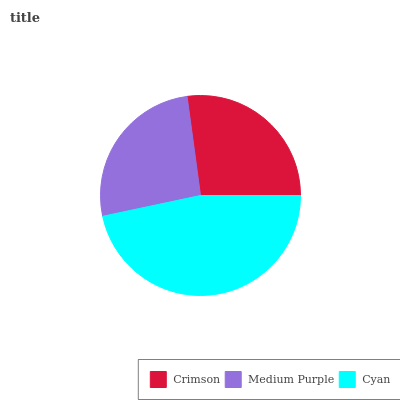Is Medium Purple the minimum?
Answer yes or no. Yes. Is Cyan the maximum?
Answer yes or no. Yes. Is Cyan the minimum?
Answer yes or no. No. Is Medium Purple the maximum?
Answer yes or no. No. Is Cyan greater than Medium Purple?
Answer yes or no. Yes. Is Medium Purple less than Cyan?
Answer yes or no. Yes. Is Medium Purple greater than Cyan?
Answer yes or no. No. Is Cyan less than Medium Purple?
Answer yes or no. No. Is Crimson the high median?
Answer yes or no. Yes. Is Crimson the low median?
Answer yes or no. Yes. Is Cyan the high median?
Answer yes or no. No. Is Medium Purple the low median?
Answer yes or no. No. 